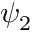Convert formula to latex. <formula><loc_0><loc_0><loc_500><loc_500>\psi _ { 2 }</formula> 